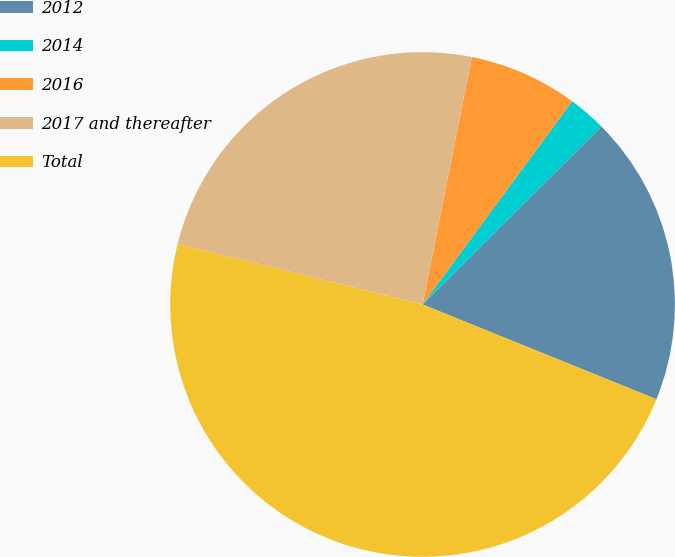Convert chart. <chart><loc_0><loc_0><loc_500><loc_500><pie_chart><fcel>2012<fcel>2014<fcel>2016<fcel>2017 and thereafter<fcel>Total<nl><fcel>18.59%<fcel>2.44%<fcel>6.97%<fcel>24.27%<fcel>47.74%<nl></chart> 